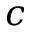<formula> <loc_0><loc_0><loc_500><loc_500>c</formula> 